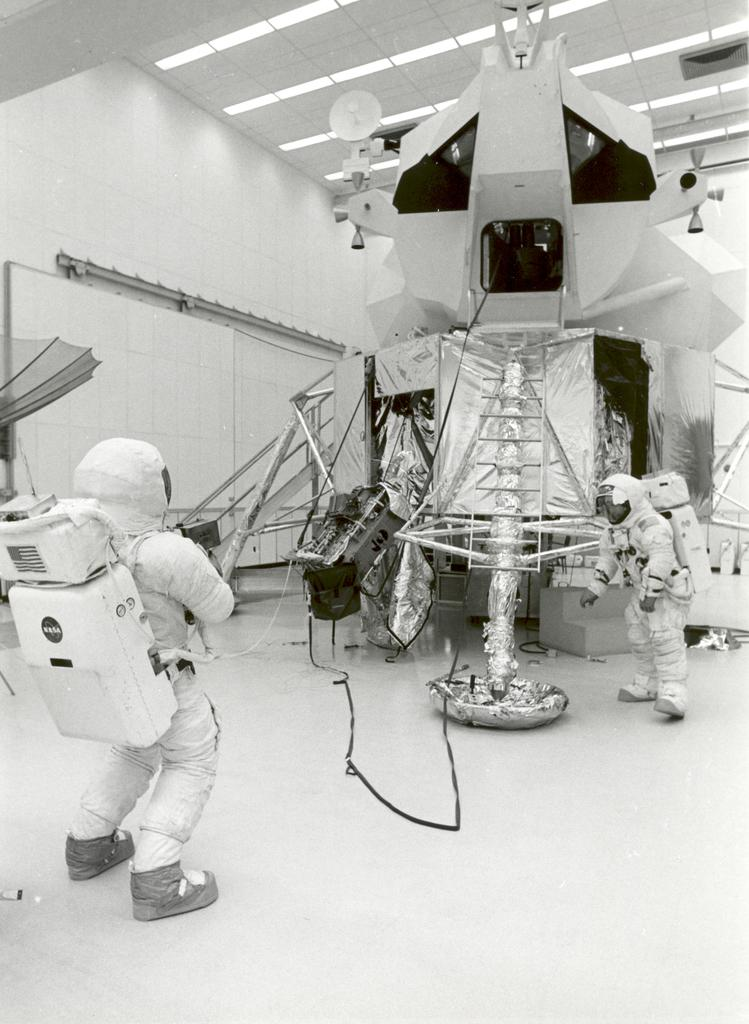How many people are in the image? There are two persons in the image. What are the persons wearing? The persons are wearing space suits. Where are the persons standing? The persons are standing on the floor. What can be seen in the image besides the persons? There is a machine visible in the image. What is visible in the background of the image? There is a wall and ceiling lights in the background of the image. How many babies are crawling on the floor in the image? There are no babies present in the image; the persons in the image are wearing space suits and standing on the floor. 